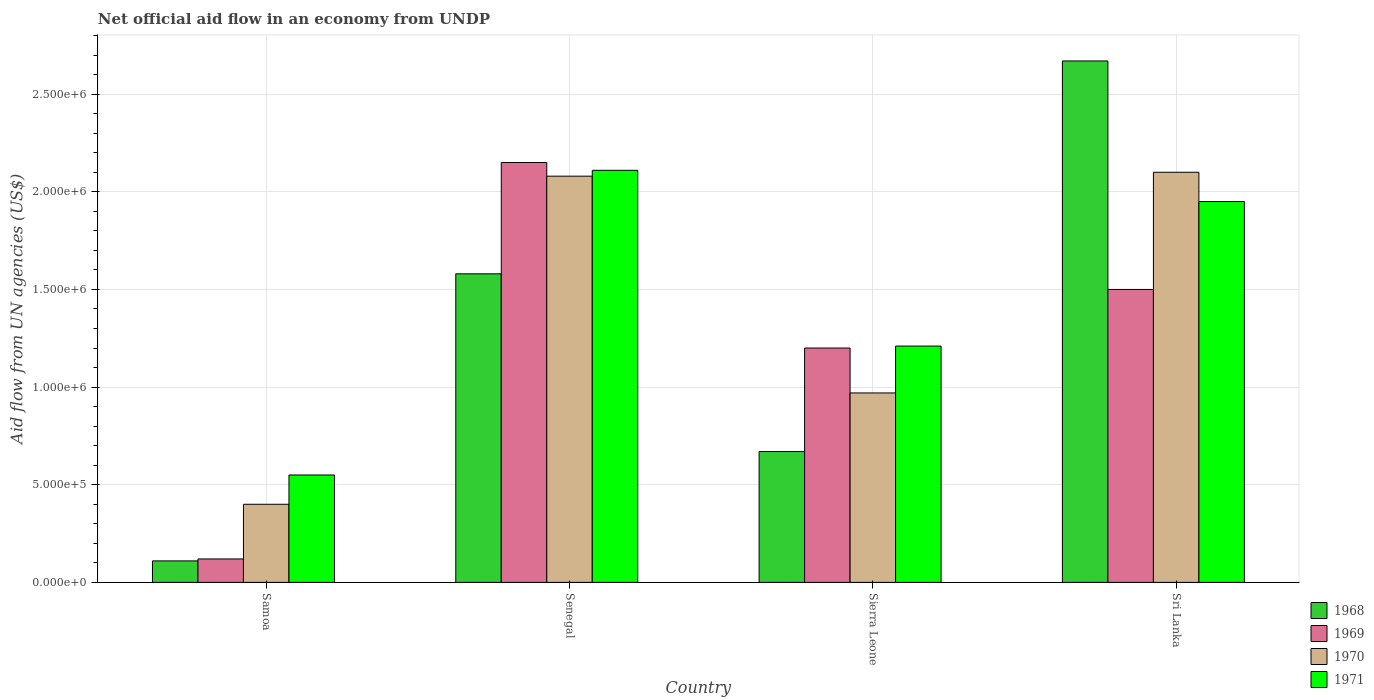How many groups of bars are there?
Your response must be concise. 4. What is the label of the 2nd group of bars from the left?
Ensure brevity in your answer.  Senegal. What is the net official aid flow in 1971 in Sierra Leone?
Offer a terse response. 1.21e+06. Across all countries, what is the maximum net official aid flow in 1969?
Your response must be concise. 2.15e+06. Across all countries, what is the minimum net official aid flow in 1969?
Make the answer very short. 1.20e+05. In which country was the net official aid flow in 1971 maximum?
Give a very brief answer. Senegal. In which country was the net official aid flow in 1968 minimum?
Your response must be concise. Samoa. What is the total net official aid flow in 1969 in the graph?
Keep it short and to the point. 4.97e+06. What is the difference between the net official aid flow in 1970 in Samoa and that in Sierra Leone?
Your answer should be very brief. -5.70e+05. What is the average net official aid flow in 1969 per country?
Make the answer very short. 1.24e+06. What is the difference between the net official aid flow of/in 1969 and net official aid flow of/in 1970 in Samoa?
Make the answer very short. -2.80e+05. What is the ratio of the net official aid flow in 1968 in Samoa to that in Sri Lanka?
Your answer should be compact. 0.04. Is the net official aid flow in 1969 in Senegal less than that in Sri Lanka?
Give a very brief answer. No. What is the difference between the highest and the second highest net official aid flow in 1969?
Ensure brevity in your answer.  6.50e+05. What is the difference between the highest and the lowest net official aid flow in 1970?
Ensure brevity in your answer.  1.70e+06. In how many countries, is the net official aid flow in 1968 greater than the average net official aid flow in 1968 taken over all countries?
Your response must be concise. 2. Is it the case that in every country, the sum of the net official aid flow in 1971 and net official aid flow in 1969 is greater than the sum of net official aid flow in 1970 and net official aid flow in 1968?
Provide a succinct answer. No. What does the 2nd bar from the left in Samoa represents?
Ensure brevity in your answer.  1969. What does the 3rd bar from the right in Sierra Leone represents?
Provide a short and direct response. 1969. Is it the case that in every country, the sum of the net official aid flow in 1968 and net official aid flow in 1970 is greater than the net official aid flow in 1969?
Provide a short and direct response. Yes. How many bars are there?
Make the answer very short. 16. Does the graph contain grids?
Keep it short and to the point. Yes. Where does the legend appear in the graph?
Provide a succinct answer. Bottom right. How are the legend labels stacked?
Provide a succinct answer. Vertical. What is the title of the graph?
Offer a terse response. Net official aid flow in an economy from UNDP. Does "1978" appear as one of the legend labels in the graph?
Make the answer very short. No. What is the label or title of the Y-axis?
Keep it short and to the point. Aid flow from UN agencies (US$). What is the Aid flow from UN agencies (US$) in 1968 in Samoa?
Provide a short and direct response. 1.10e+05. What is the Aid flow from UN agencies (US$) in 1970 in Samoa?
Make the answer very short. 4.00e+05. What is the Aid flow from UN agencies (US$) of 1971 in Samoa?
Offer a very short reply. 5.50e+05. What is the Aid flow from UN agencies (US$) of 1968 in Senegal?
Provide a succinct answer. 1.58e+06. What is the Aid flow from UN agencies (US$) in 1969 in Senegal?
Keep it short and to the point. 2.15e+06. What is the Aid flow from UN agencies (US$) in 1970 in Senegal?
Keep it short and to the point. 2.08e+06. What is the Aid flow from UN agencies (US$) in 1971 in Senegal?
Provide a short and direct response. 2.11e+06. What is the Aid flow from UN agencies (US$) in 1968 in Sierra Leone?
Your answer should be compact. 6.70e+05. What is the Aid flow from UN agencies (US$) in 1969 in Sierra Leone?
Offer a very short reply. 1.20e+06. What is the Aid flow from UN agencies (US$) of 1970 in Sierra Leone?
Provide a short and direct response. 9.70e+05. What is the Aid flow from UN agencies (US$) in 1971 in Sierra Leone?
Your response must be concise. 1.21e+06. What is the Aid flow from UN agencies (US$) of 1968 in Sri Lanka?
Make the answer very short. 2.67e+06. What is the Aid flow from UN agencies (US$) of 1969 in Sri Lanka?
Make the answer very short. 1.50e+06. What is the Aid flow from UN agencies (US$) in 1970 in Sri Lanka?
Your answer should be very brief. 2.10e+06. What is the Aid flow from UN agencies (US$) in 1971 in Sri Lanka?
Your answer should be compact. 1.95e+06. Across all countries, what is the maximum Aid flow from UN agencies (US$) in 1968?
Keep it short and to the point. 2.67e+06. Across all countries, what is the maximum Aid flow from UN agencies (US$) in 1969?
Give a very brief answer. 2.15e+06. Across all countries, what is the maximum Aid flow from UN agencies (US$) of 1970?
Keep it short and to the point. 2.10e+06. Across all countries, what is the maximum Aid flow from UN agencies (US$) in 1971?
Keep it short and to the point. 2.11e+06. What is the total Aid flow from UN agencies (US$) in 1968 in the graph?
Offer a very short reply. 5.03e+06. What is the total Aid flow from UN agencies (US$) of 1969 in the graph?
Offer a very short reply. 4.97e+06. What is the total Aid flow from UN agencies (US$) in 1970 in the graph?
Your response must be concise. 5.55e+06. What is the total Aid flow from UN agencies (US$) of 1971 in the graph?
Your answer should be very brief. 5.82e+06. What is the difference between the Aid flow from UN agencies (US$) of 1968 in Samoa and that in Senegal?
Your response must be concise. -1.47e+06. What is the difference between the Aid flow from UN agencies (US$) in 1969 in Samoa and that in Senegal?
Make the answer very short. -2.03e+06. What is the difference between the Aid flow from UN agencies (US$) of 1970 in Samoa and that in Senegal?
Give a very brief answer. -1.68e+06. What is the difference between the Aid flow from UN agencies (US$) of 1971 in Samoa and that in Senegal?
Offer a very short reply. -1.56e+06. What is the difference between the Aid flow from UN agencies (US$) in 1968 in Samoa and that in Sierra Leone?
Provide a short and direct response. -5.60e+05. What is the difference between the Aid flow from UN agencies (US$) in 1969 in Samoa and that in Sierra Leone?
Offer a terse response. -1.08e+06. What is the difference between the Aid flow from UN agencies (US$) of 1970 in Samoa and that in Sierra Leone?
Provide a succinct answer. -5.70e+05. What is the difference between the Aid flow from UN agencies (US$) of 1971 in Samoa and that in Sierra Leone?
Offer a terse response. -6.60e+05. What is the difference between the Aid flow from UN agencies (US$) in 1968 in Samoa and that in Sri Lanka?
Ensure brevity in your answer.  -2.56e+06. What is the difference between the Aid flow from UN agencies (US$) of 1969 in Samoa and that in Sri Lanka?
Give a very brief answer. -1.38e+06. What is the difference between the Aid flow from UN agencies (US$) of 1970 in Samoa and that in Sri Lanka?
Give a very brief answer. -1.70e+06. What is the difference between the Aid flow from UN agencies (US$) of 1971 in Samoa and that in Sri Lanka?
Provide a short and direct response. -1.40e+06. What is the difference between the Aid flow from UN agencies (US$) of 1968 in Senegal and that in Sierra Leone?
Ensure brevity in your answer.  9.10e+05. What is the difference between the Aid flow from UN agencies (US$) in 1969 in Senegal and that in Sierra Leone?
Provide a succinct answer. 9.50e+05. What is the difference between the Aid flow from UN agencies (US$) of 1970 in Senegal and that in Sierra Leone?
Your answer should be compact. 1.11e+06. What is the difference between the Aid flow from UN agencies (US$) in 1971 in Senegal and that in Sierra Leone?
Offer a terse response. 9.00e+05. What is the difference between the Aid flow from UN agencies (US$) in 1968 in Senegal and that in Sri Lanka?
Ensure brevity in your answer.  -1.09e+06. What is the difference between the Aid flow from UN agencies (US$) in 1969 in Senegal and that in Sri Lanka?
Offer a terse response. 6.50e+05. What is the difference between the Aid flow from UN agencies (US$) of 1970 in Senegal and that in Sri Lanka?
Make the answer very short. -2.00e+04. What is the difference between the Aid flow from UN agencies (US$) of 1971 in Senegal and that in Sri Lanka?
Make the answer very short. 1.60e+05. What is the difference between the Aid flow from UN agencies (US$) in 1968 in Sierra Leone and that in Sri Lanka?
Make the answer very short. -2.00e+06. What is the difference between the Aid flow from UN agencies (US$) in 1969 in Sierra Leone and that in Sri Lanka?
Offer a terse response. -3.00e+05. What is the difference between the Aid flow from UN agencies (US$) of 1970 in Sierra Leone and that in Sri Lanka?
Offer a very short reply. -1.13e+06. What is the difference between the Aid flow from UN agencies (US$) in 1971 in Sierra Leone and that in Sri Lanka?
Provide a succinct answer. -7.40e+05. What is the difference between the Aid flow from UN agencies (US$) of 1968 in Samoa and the Aid flow from UN agencies (US$) of 1969 in Senegal?
Provide a short and direct response. -2.04e+06. What is the difference between the Aid flow from UN agencies (US$) of 1968 in Samoa and the Aid flow from UN agencies (US$) of 1970 in Senegal?
Keep it short and to the point. -1.97e+06. What is the difference between the Aid flow from UN agencies (US$) of 1968 in Samoa and the Aid flow from UN agencies (US$) of 1971 in Senegal?
Your answer should be very brief. -2.00e+06. What is the difference between the Aid flow from UN agencies (US$) of 1969 in Samoa and the Aid flow from UN agencies (US$) of 1970 in Senegal?
Keep it short and to the point. -1.96e+06. What is the difference between the Aid flow from UN agencies (US$) in 1969 in Samoa and the Aid flow from UN agencies (US$) in 1971 in Senegal?
Give a very brief answer. -1.99e+06. What is the difference between the Aid flow from UN agencies (US$) of 1970 in Samoa and the Aid flow from UN agencies (US$) of 1971 in Senegal?
Offer a terse response. -1.71e+06. What is the difference between the Aid flow from UN agencies (US$) of 1968 in Samoa and the Aid flow from UN agencies (US$) of 1969 in Sierra Leone?
Provide a short and direct response. -1.09e+06. What is the difference between the Aid flow from UN agencies (US$) in 1968 in Samoa and the Aid flow from UN agencies (US$) in 1970 in Sierra Leone?
Offer a terse response. -8.60e+05. What is the difference between the Aid flow from UN agencies (US$) in 1968 in Samoa and the Aid flow from UN agencies (US$) in 1971 in Sierra Leone?
Give a very brief answer. -1.10e+06. What is the difference between the Aid flow from UN agencies (US$) in 1969 in Samoa and the Aid flow from UN agencies (US$) in 1970 in Sierra Leone?
Provide a short and direct response. -8.50e+05. What is the difference between the Aid flow from UN agencies (US$) of 1969 in Samoa and the Aid flow from UN agencies (US$) of 1971 in Sierra Leone?
Ensure brevity in your answer.  -1.09e+06. What is the difference between the Aid flow from UN agencies (US$) of 1970 in Samoa and the Aid flow from UN agencies (US$) of 1971 in Sierra Leone?
Your answer should be compact. -8.10e+05. What is the difference between the Aid flow from UN agencies (US$) in 1968 in Samoa and the Aid flow from UN agencies (US$) in 1969 in Sri Lanka?
Offer a very short reply. -1.39e+06. What is the difference between the Aid flow from UN agencies (US$) in 1968 in Samoa and the Aid flow from UN agencies (US$) in 1970 in Sri Lanka?
Offer a terse response. -1.99e+06. What is the difference between the Aid flow from UN agencies (US$) of 1968 in Samoa and the Aid flow from UN agencies (US$) of 1971 in Sri Lanka?
Offer a terse response. -1.84e+06. What is the difference between the Aid flow from UN agencies (US$) in 1969 in Samoa and the Aid flow from UN agencies (US$) in 1970 in Sri Lanka?
Offer a terse response. -1.98e+06. What is the difference between the Aid flow from UN agencies (US$) of 1969 in Samoa and the Aid flow from UN agencies (US$) of 1971 in Sri Lanka?
Offer a terse response. -1.83e+06. What is the difference between the Aid flow from UN agencies (US$) in 1970 in Samoa and the Aid flow from UN agencies (US$) in 1971 in Sri Lanka?
Make the answer very short. -1.55e+06. What is the difference between the Aid flow from UN agencies (US$) of 1968 in Senegal and the Aid flow from UN agencies (US$) of 1970 in Sierra Leone?
Offer a very short reply. 6.10e+05. What is the difference between the Aid flow from UN agencies (US$) in 1969 in Senegal and the Aid flow from UN agencies (US$) in 1970 in Sierra Leone?
Your response must be concise. 1.18e+06. What is the difference between the Aid flow from UN agencies (US$) in 1969 in Senegal and the Aid flow from UN agencies (US$) in 1971 in Sierra Leone?
Your answer should be very brief. 9.40e+05. What is the difference between the Aid flow from UN agencies (US$) in 1970 in Senegal and the Aid flow from UN agencies (US$) in 1971 in Sierra Leone?
Your answer should be very brief. 8.70e+05. What is the difference between the Aid flow from UN agencies (US$) in 1968 in Senegal and the Aid flow from UN agencies (US$) in 1969 in Sri Lanka?
Provide a short and direct response. 8.00e+04. What is the difference between the Aid flow from UN agencies (US$) in 1968 in Senegal and the Aid flow from UN agencies (US$) in 1970 in Sri Lanka?
Provide a short and direct response. -5.20e+05. What is the difference between the Aid flow from UN agencies (US$) in 1968 in Senegal and the Aid flow from UN agencies (US$) in 1971 in Sri Lanka?
Give a very brief answer. -3.70e+05. What is the difference between the Aid flow from UN agencies (US$) in 1969 in Senegal and the Aid flow from UN agencies (US$) in 1970 in Sri Lanka?
Ensure brevity in your answer.  5.00e+04. What is the difference between the Aid flow from UN agencies (US$) in 1969 in Senegal and the Aid flow from UN agencies (US$) in 1971 in Sri Lanka?
Offer a terse response. 2.00e+05. What is the difference between the Aid flow from UN agencies (US$) of 1968 in Sierra Leone and the Aid flow from UN agencies (US$) of 1969 in Sri Lanka?
Provide a succinct answer. -8.30e+05. What is the difference between the Aid flow from UN agencies (US$) in 1968 in Sierra Leone and the Aid flow from UN agencies (US$) in 1970 in Sri Lanka?
Offer a terse response. -1.43e+06. What is the difference between the Aid flow from UN agencies (US$) of 1968 in Sierra Leone and the Aid flow from UN agencies (US$) of 1971 in Sri Lanka?
Keep it short and to the point. -1.28e+06. What is the difference between the Aid flow from UN agencies (US$) of 1969 in Sierra Leone and the Aid flow from UN agencies (US$) of 1970 in Sri Lanka?
Ensure brevity in your answer.  -9.00e+05. What is the difference between the Aid flow from UN agencies (US$) of 1969 in Sierra Leone and the Aid flow from UN agencies (US$) of 1971 in Sri Lanka?
Give a very brief answer. -7.50e+05. What is the difference between the Aid flow from UN agencies (US$) of 1970 in Sierra Leone and the Aid flow from UN agencies (US$) of 1971 in Sri Lanka?
Offer a terse response. -9.80e+05. What is the average Aid flow from UN agencies (US$) in 1968 per country?
Ensure brevity in your answer.  1.26e+06. What is the average Aid flow from UN agencies (US$) in 1969 per country?
Your answer should be compact. 1.24e+06. What is the average Aid flow from UN agencies (US$) in 1970 per country?
Offer a terse response. 1.39e+06. What is the average Aid flow from UN agencies (US$) in 1971 per country?
Ensure brevity in your answer.  1.46e+06. What is the difference between the Aid flow from UN agencies (US$) of 1968 and Aid flow from UN agencies (US$) of 1971 in Samoa?
Your answer should be compact. -4.40e+05. What is the difference between the Aid flow from UN agencies (US$) in 1969 and Aid flow from UN agencies (US$) in 1970 in Samoa?
Offer a very short reply. -2.80e+05. What is the difference between the Aid flow from UN agencies (US$) of 1969 and Aid flow from UN agencies (US$) of 1971 in Samoa?
Offer a terse response. -4.30e+05. What is the difference between the Aid flow from UN agencies (US$) in 1970 and Aid flow from UN agencies (US$) in 1971 in Samoa?
Give a very brief answer. -1.50e+05. What is the difference between the Aid flow from UN agencies (US$) in 1968 and Aid flow from UN agencies (US$) in 1969 in Senegal?
Ensure brevity in your answer.  -5.70e+05. What is the difference between the Aid flow from UN agencies (US$) in 1968 and Aid flow from UN agencies (US$) in 1970 in Senegal?
Offer a terse response. -5.00e+05. What is the difference between the Aid flow from UN agencies (US$) in 1968 and Aid flow from UN agencies (US$) in 1971 in Senegal?
Provide a short and direct response. -5.30e+05. What is the difference between the Aid flow from UN agencies (US$) in 1969 and Aid flow from UN agencies (US$) in 1970 in Senegal?
Your answer should be compact. 7.00e+04. What is the difference between the Aid flow from UN agencies (US$) in 1968 and Aid flow from UN agencies (US$) in 1969 in Sierra Leone?
Make the answer very short. -5.30e+05. What is the difference between the Aid flow from UN agencies (US$) in 1968 and Aid flow from UN agencies (US$) in 1970 in Sierra Leone?
Give a very brief answer. -3.00e+05. What is the difference between the Aid flow from UN agencies (US$) in 1968 and Aid flow from UN agencies (US$) in 1971 in Sierra Leone?
Your answer should be compact. -5.40e+05. What is the difference between the Aid flow from UN agencies (US$) in 1969 and Aid flow from UN agencies (US$) in 1970 in Sierra Leone?
Offer a very short reply. 2.30e+05. What is the difference between the Aid flow from UN agencies (US$) of 1970 and Aid flow from UN agencies (US$) of 1971 in Sierra Leone?
Your response must be concise. -2.40e+05. What is the difference between the Aid flow from UN agencies (US$) of 1968 and Aid flow from UN agencies (US$) of 1969 in Sri Lanka?
Offer a terse response. 1.17e+06. What is the difference between the Aid flow from UN agencies (US$) of 1968 and Aid flow from UN agencies (US$) of 1970 in Sri Lanka?
Your response must be concise. 5.70e+05. What is the difference between the Aid flow from UN agencies (US$) of 1968 and Aid flow from UN agencies (US$) of 1971 in Sri Lanka?
Your answer should be compact. 7.20e+05. What is the difference between the Aid flow from UN agencies (US$) of 1969 and Aid flow from UN agencies (US$) of 1970 in Sri Lanka?
Your response must be concise. -6.00e+05. What is the difference between the Aid flow from UN agencies (US$) of 1969 and Aid flow from UN agencies (US$) of 1971 in Sri Lanka?
Your answer should be very brief. -4.50e+05. What is the difference between the Aid flow from UN agencies (US$) in 1970 and Aid flow from UN agencies (US$) in 1971 in Sri Lanka?
Keep it short and to the point. 1.50e+05. What is the ratio of the Aid flow from UN agencies (US$) in 1968 in Samoa to that in Senegal?
Offer a terse response. 0.07. What is the ratio of the Aid flow from UN agencies (US$) in 1969 in Samoa to that in Senegal?
Your answer should be very brief. 0.06. What is the ratio of the Aid flow from UN agencies (US$) of 1970 in Samoa to that in Senegal?
Your response must be concise. 0.19. What is the ratio of the Aid flow from UN agencies (US$) in 1971 in Samoa to that in Senegal?
Ensure brevity in your answer.  0.26. What is the ratio of the Aid flow from UN agencies (US$) of 1968 in Samoa to that in Sierra Leone?
Offer a terse response. 0.16. What is the ratio of the Aid flow from UN agencies (US$) in 1969 in Samoa to that in Sierra Leone?
Ensure brevity in your answer.  0.1. What is the ratio of the Aid flow from UN agencies (US$) of 1970 in Samoa to that in Sierra Leone?
Keep it short and to the point. 0.41. What is the ratio of the Aid flow from UN agencies (US$) of 1971 in Samoa to that in Sierra Leone?
Your response must be concise. 0.45. What is the ratio of the Aid flow from UN agencies (US$) of 1968 in Samoa to that in Sri Lanka?
Offer a very short reply. 0.04. What is the ratio of the Aid flow from UN agencies (US$) of 1970 in Samoa to that in Sri Lanka?
Make the answer very short. 0.19. What is the ratio of the Aid flow from UN agencies (US$) of 1971 in Samoa to that in Sri Lanka?
Your response must be concise. 0.28. What is the ratio of the Aid flow from UN agencies (US$) in 1968 in Senegal to that in Sierra Leone?
Give a very brief answer. 2.36. What is the ratio of the Aid flow from UN agencies (US$) of 1969 in Senegal to that in Sierra Leone?
Give a very brief answer. 1.79. What is the ratio of the Aid flow from UN agencies (US$) of 1970 in Senegal to that in Sierra Leone?
Give a very brief answer. 2.14. What is the ratio of the Aid flow from UN agencies (US$) in 1971 in Senegal to that in Sierra Leone?
Your answer should be compact. 1.74. What is the ratio of the Aid flow from UN agencies (US$) of 1968 in Senegal to that in Sri Lanka?
Offer a very short reply. 0.59. What is the ratio of the Aid flow from UN agencies (US$) of 1969 in Senegal to that in Sri Lanka?
Make the answer very short. 1.43. What is the ratio of the Aid flow from UN agencies (US$) of 1970 in Senegal to that in Sri Lanka?
Give a very brief answer. 0.99. What is the ratio of the Aid flow from UN agencies (US$) in 1971 in Senegal to that in Sri Lanka?
Ensure brevity in your answer.  1.08. What is the ratio of the Aid flow from UN agencies (US$) of 1968 in Sierra Leone to that in Sri Lanka?
Make the answer very short. 0.25. What is the ratio of the Aid flow from UN agencies (US$) in 1970 in Sierra Leone to that in Sri Lanka?
Your response must be concise. 0.46. What is the ratio of the Aid flow from UN agencies (US$) of 1971 in Sierra Leone to that in Sri Lanka?
Provide a short and direct response. 0.62. What is the difference between the highest and the second highest Aid flow from UN agencies (US$) of 1968?
Give a very brief answer. 1.09e+06. What is the difference between the highest and the second highest Aid flow from UN agencies (US$) in 1969?
Provide a short and direct response. 6.50e+05. What is the difference between the highest and the lowest Aid flow from UN agencies (US$) in 1968?
Your answer should be very brief. 2.56e+06. What is the difference between the highest and the lowest Aid flow from UN agencies (US$) in 1969?
Keep it short and to the point. 2.03e+06. What is the difference between the highest and the lowest Aid flow from UN agencies (US$) in 1970?
Make the answer very short. 1.70e+06. What is the difference between the highest and the lowest Aid flow from UN agencies (US$) in 1971?
Make the answer very short. 1.56e+06. 